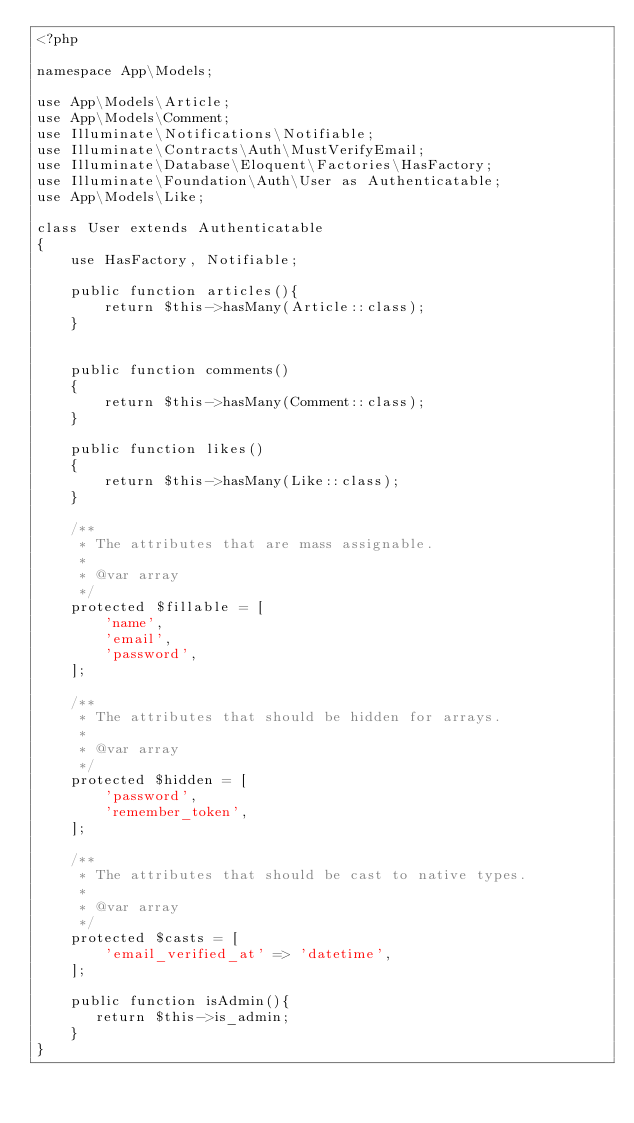Convert code to text. <code><loc_0><loc_0><loc_500><loc_500><_PHP_><?php

namespace App\Models;

use App\Models\Article;
use App\Models\Comment;
use Illuminate\Notifications\Notifiable;
use Illuminate\Contracts\Auth\MustVerifyEmail;
use Illuminate\Database\Eloquent\Factories\HasFactory;
use Illuminate\Foundation\Auth\User as Authenticatable;
use App\Models\Like;

class User extends Authenticatable
{
    use HasFactory, Notifiable;

    public function articles(){
        return $this->hasMany(Article::class);
    }
    

    public function comments()
    {
        return $this->hasMany(Comment::class);
    }

    public function likes()
    {
        return $this->hasMany(Like::class);
    }

    /**
     * The attributes that are mass assignable.
     *
     * @var array
     */
    protected $fillable = [
        'name',
        'email',
        'password',
    ];

    /**
     * The attributes that should be hidden for arrays.
     *
     * @var array
     */
    protected $hidden = [
        'password',
        'remember_token',
    ];

    /**
     * The attributes that should be cast to native types.
     *
     * @var array
     */
    protected $casts = [
        'email_verified_at' => 'datetime',
    ];

    public function isAdmin(){
       return $this->is_admin;
    }
}
</code> 